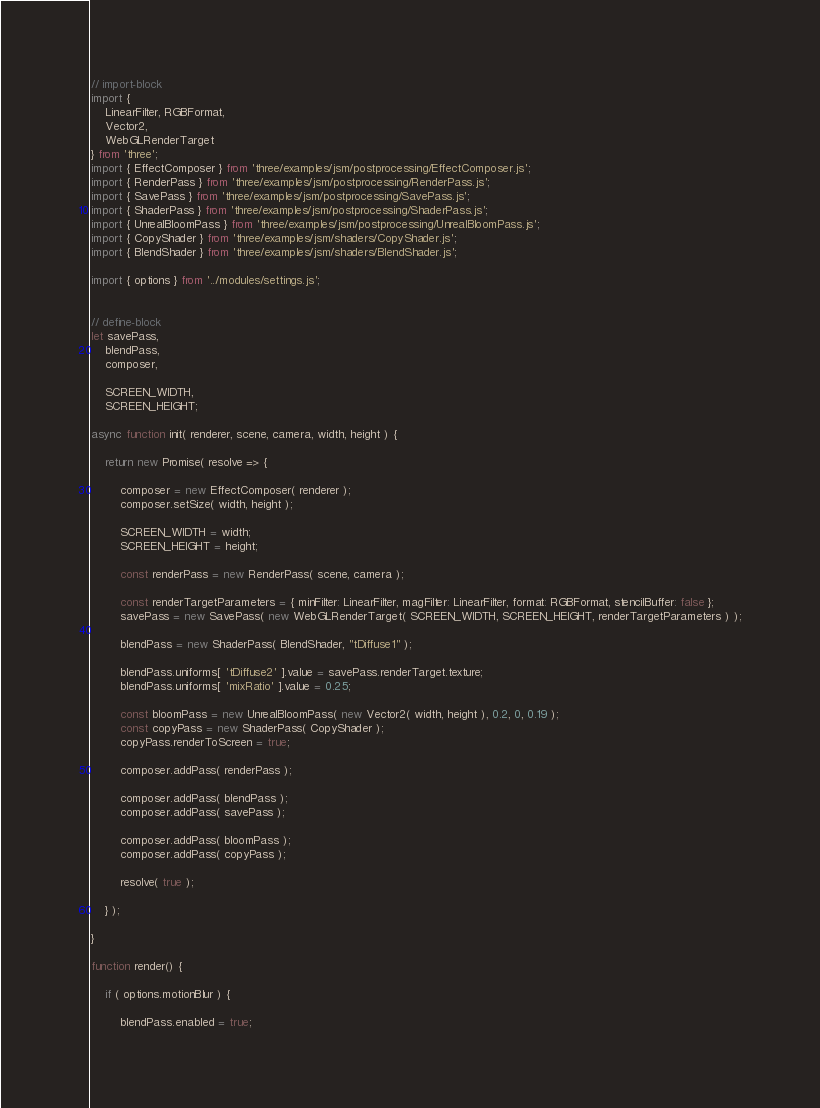<code> <loc_0><loc_0><loc_500><loc_500><_JavaScript_>// import-block
import {
	LinearFilter, RGBFormat,
	Vector2,
	WebGLRenderTarget
} from 'three';
import { EffectComposer } from 'three/examples/jsm/postprocessing/EffectComposer.js';
import { RenderPass } from 'three/examples/jsm/postprocessing/RenderPass.js';
import { SavePass } from 'three/examples/jsm/postprocessing/SavePass.js';
import { ShaderPass } from 'three/examples/jsm/postprocessing/ShaderPass.js';
import { UnrealBloomPass } from 'three/examples/jsm/postprocessing/UnrealBloomPass.js';
import { CopyShader } from 'three/examples/jsm/shaders/CopyShader.js';
import { BlendShader } from 'three/examples/jsm/shaders/BlendShader.js';

import { options } from '../modules/settings.js';


// define-block
let savePass,
	blendPass,
	composer,

	SCREEN_WIDTH,
	SCREEN_HEIGHT;

async function init( renderer, scene, camera, width, height ) {

	return new Promise( resolve => {

		composer = new EffectComposer( renderer );
		composer.setSize( width, height );

		SCREEN_WIDTH = width;
		SCREEN_HEIGHT = height;

		const renderPass = new RenderPass( scene, camera );

		const renderTargetParameters = { minFilter: LinearFilter, magFilter: LinearFilter, format: RGBFormat, stencilBuffer: false };
		savePass = new SavePass( new WebGLRenderTarget( SCREEN_WIDTH, SCREEN_HEIGHT, renderTargetParameters ) );

		blendPass = new ShaderPass( BlendShader, "tDiffuse1" );

		blendPass.uniforms[ 'tDiffuse2' ].value = savePass.renderTarget.texture;
		blendPass.uniforms[ 'mixRatio' ].value = 0.25;

		const bloomPass = new UnrealBloomPass( new Vector2( width, height ), 0.2, 0, 0.19 );
		const copyPass = new ShaderPass( CopyShader );
		copyPass.renderToScreen = true;

		composer.addPass( renderPass );

		composer.addPass( blendPass );
		composer.addPass( savePass );

		composer.addPass( bloomPass );
		composer.addPass( copyPass );

		resolve( true );

	} );

}

function render() {

	if ( options.motionBlur ) {

		blendPass.enabled = true;</code> 